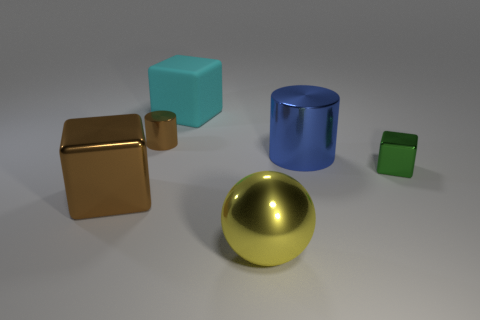Add 2 big blue shiny cylinders. How many objects exist? 8 Subtract all cylinders. How many objects are left? 4 Subtract all gray metallic cylinders. Subtract all brown blocks. How many objects are left? 5 Add 2 green things. How many green things are left? 3 Add 3 large things. How many large things exist? 7 Subtract 1 blue cylinders. How many objects are left? 5 